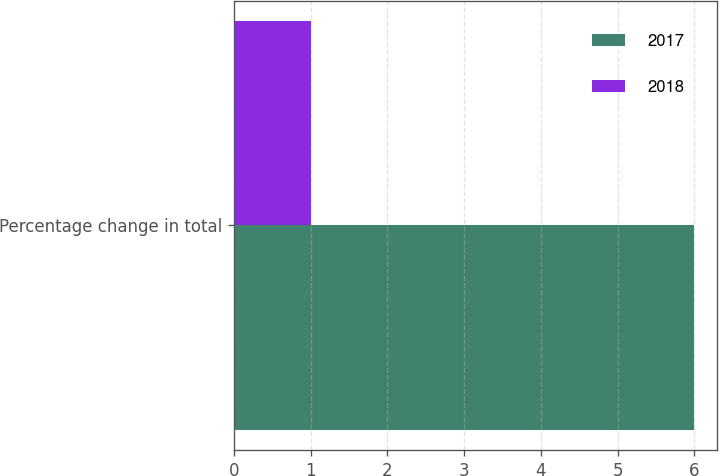Convert chart to OTSL. <chart><loc_0><loc_0><loc_500><loc_500><stacked_bar_chart><ecel><fcel>Percentage change in total<nl><fcel>2017<fcel>6<nl><fcel>2018<fcel>1<nl></chart> 